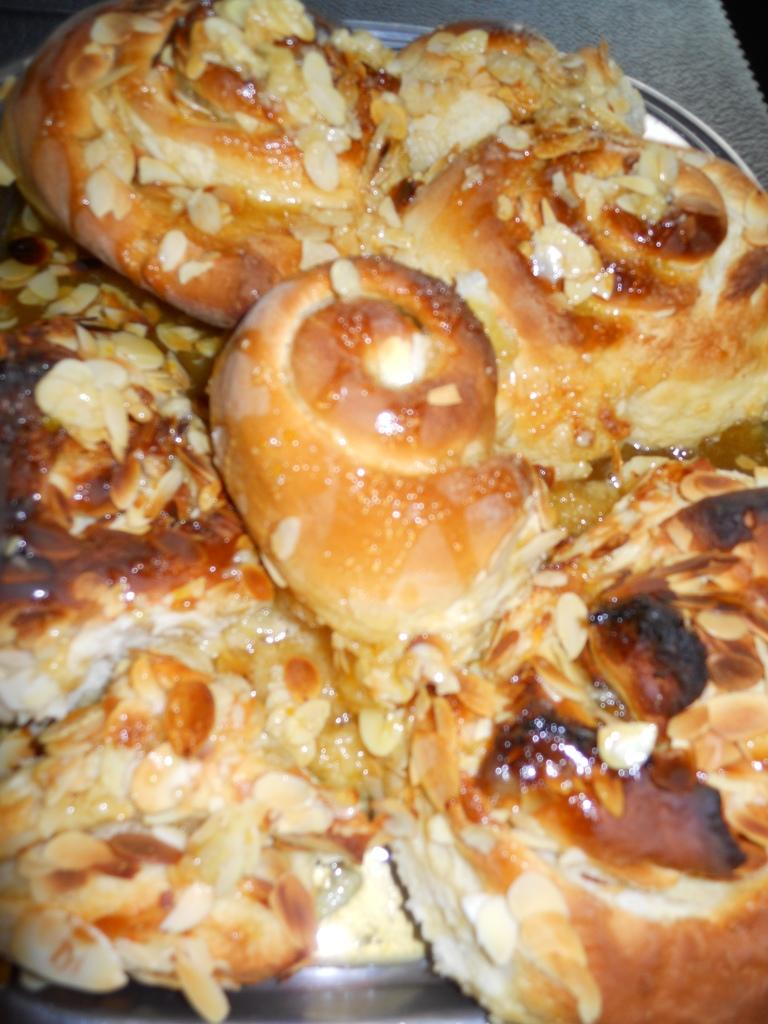What type of food can be seen in the image? The image contains a food item. What is the food item made of? The food item is made of bread and other ingredients. How is the food item presented in the image? The food item is placed on a plate. How many hearts can be seen in the image? There are no hearts visible in the image. 